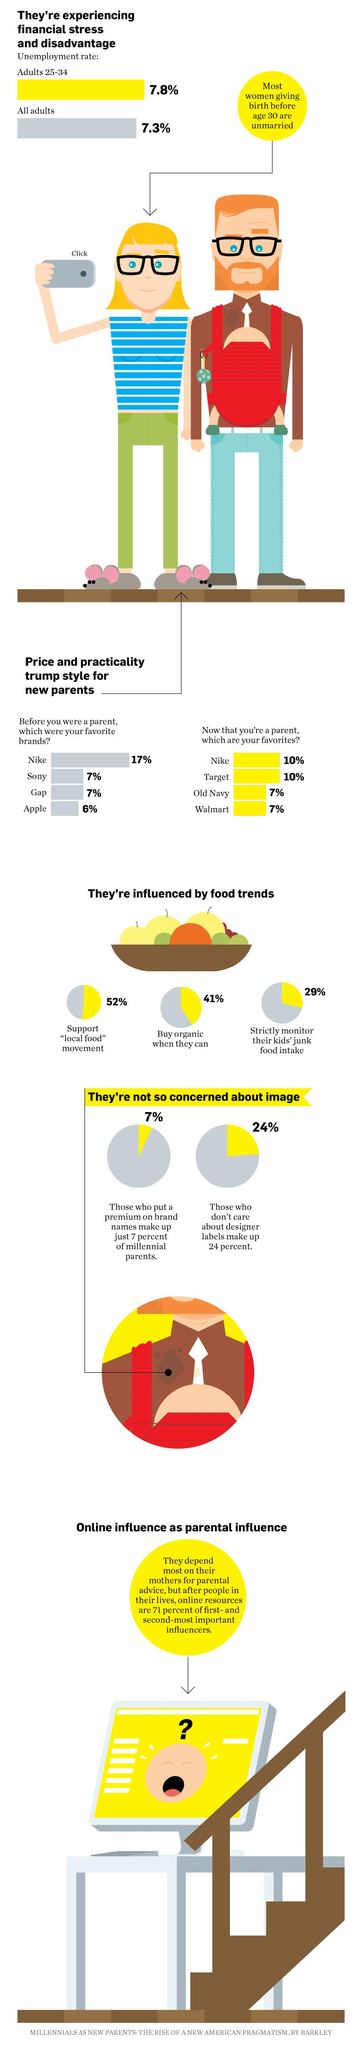Point out several critical features in this image. According to a recent survey, 52% of people support the "local food" movement. According to the survey, 29% of people strictly monitor their children's junk food intake. People's favorite brands before they became parents are often different from their current preferences. In particular, many individuals once held a strong affinity for Nike. According to a recent survey, 41% of people purchase organic products when they have the option to do so. 